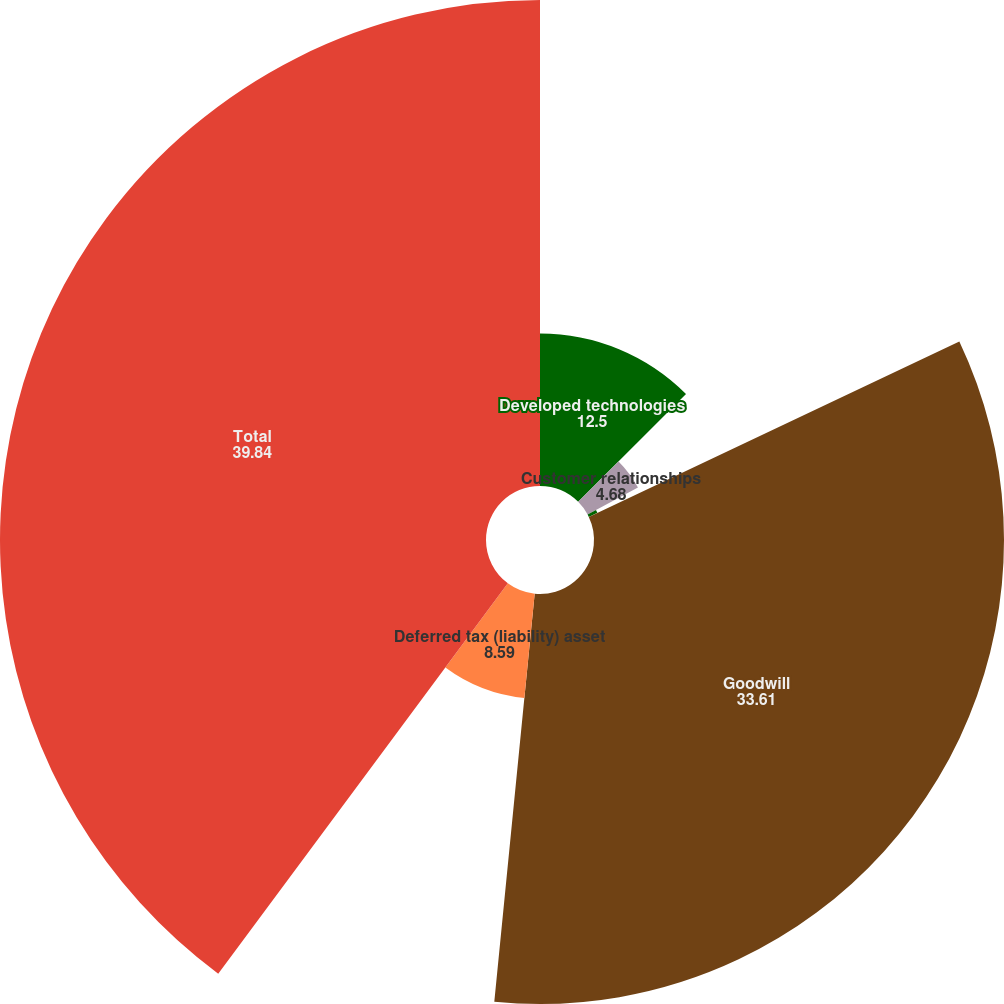<chart> <loc_0><loc_0><loc_500><loc_500><pie_chart><fcel>Developed technologies<fcel>Customer relationships<fcel>Trade name<fcel>Goodwill<fcel>Deferred tax (liability) asset<fcel>Total<nl><fcel>12.5%<fcel>4.68%<fcel>0.78%<fcel>33.61%<fcel>8.59%<fcel>39.84%<nl></chart> 